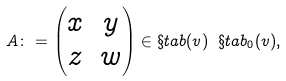Convert formula to latex. <formula><loc_0><loc_0><loc_500><loc_500>A \colon = \begin{pmatrix} x & y \\ z & w \end{pmatrix} \in \S t a b ( v ) \ \S t a b _ { 0 } ( v ) ,</formula> 